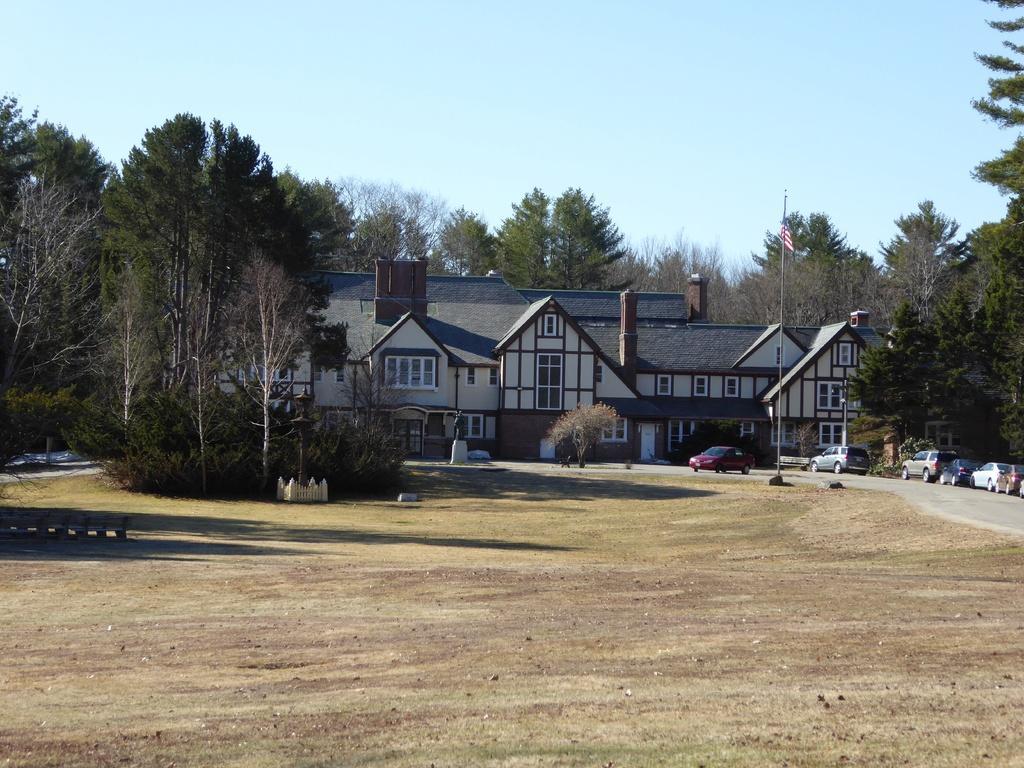Could you give a brief overview of what you see in this image? In the center of the image there is a building and we can see trees. On the right there are cars on the road. In the background there is sky. We can see a flag. 